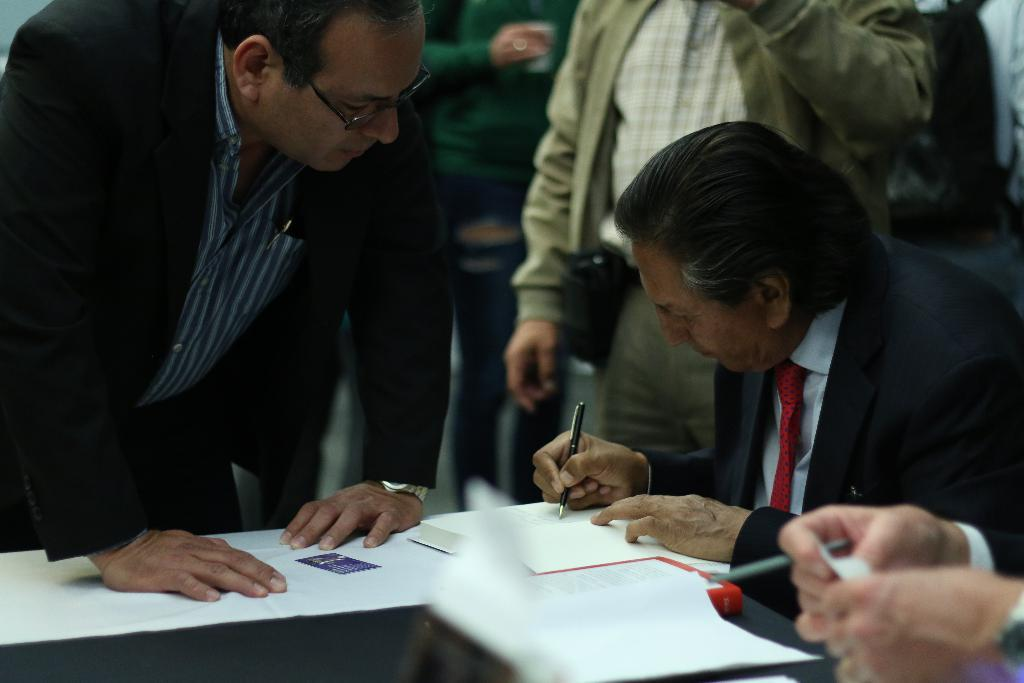Who is the main subject in the image? The main subject in the image is an old man. What is the old man doing in the image? The old man is writing something in a book. On which side of the image is the old man located? The old man is on the right side of the image. Are there any other people in the image? Yes, there are other people standing in the image. Where are the other people in relation to the old man? The other people are at the back of the old man. What type of advertisement can be seen on the matchbox in the image? There is no matchbox or advertisement present in the image. What knowledge does the old man possess about the subject he is writing about in the image? The image does not provide any information about the old man's knowledge on the subject he is writing about. 